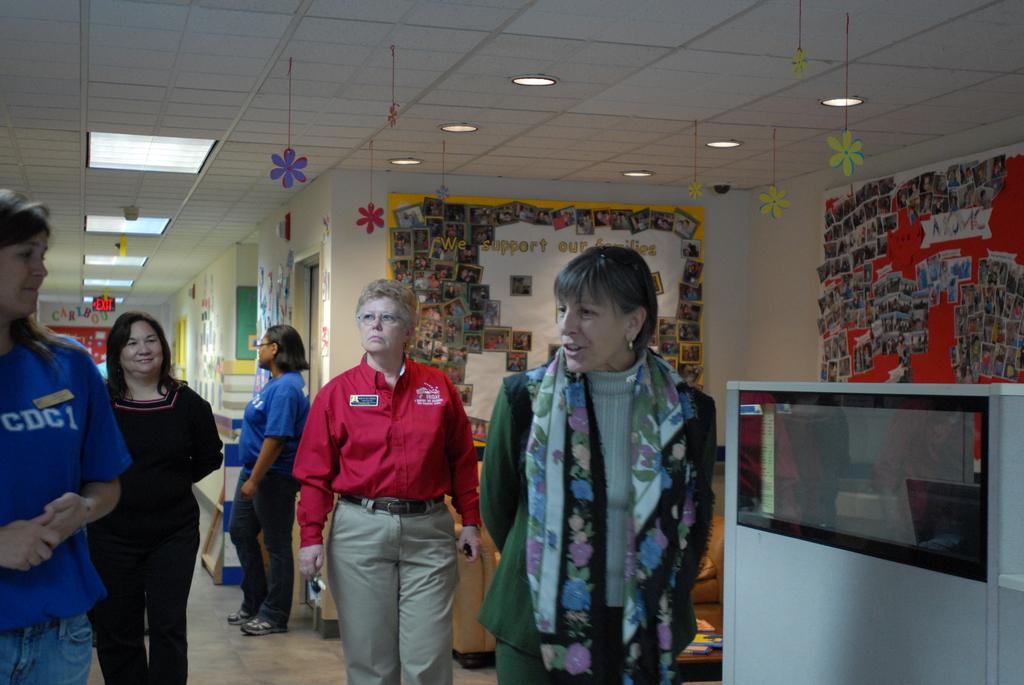What is on the blue shirt?
Your response must be concise. Cdci. Cdc is on the shirt to the far left or right?
Offer a terse response. Left. 